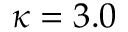<formula> <loc_0><loc_0><loc_500><loc_500>\kappa = 3 . 0</formula> 